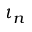Convert formula to latex. <formula><loc_0><loc_0><loc_500><loc_500>\iota _ { n }</formula> 